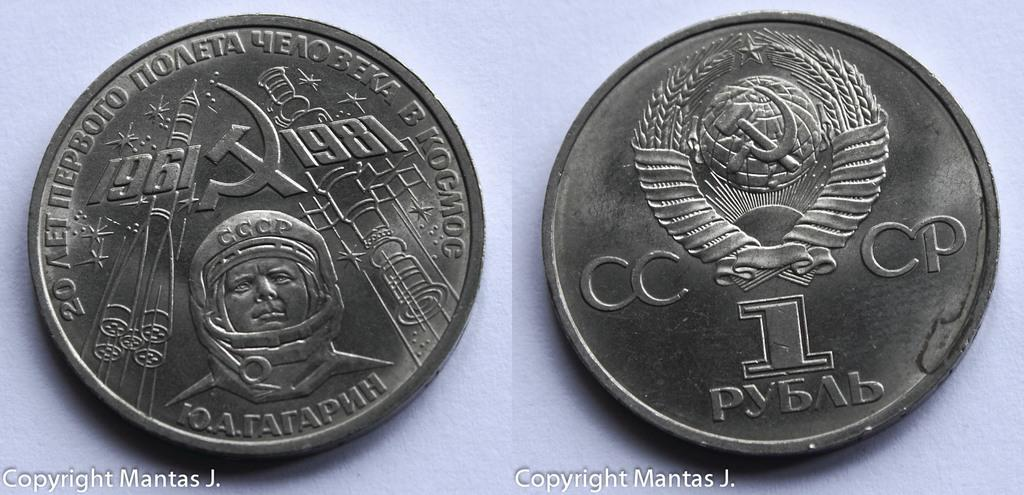<image>
Give a short and clear explanation of the subsequent image. The front and backside of a silver coin from a foreign country are showing. 